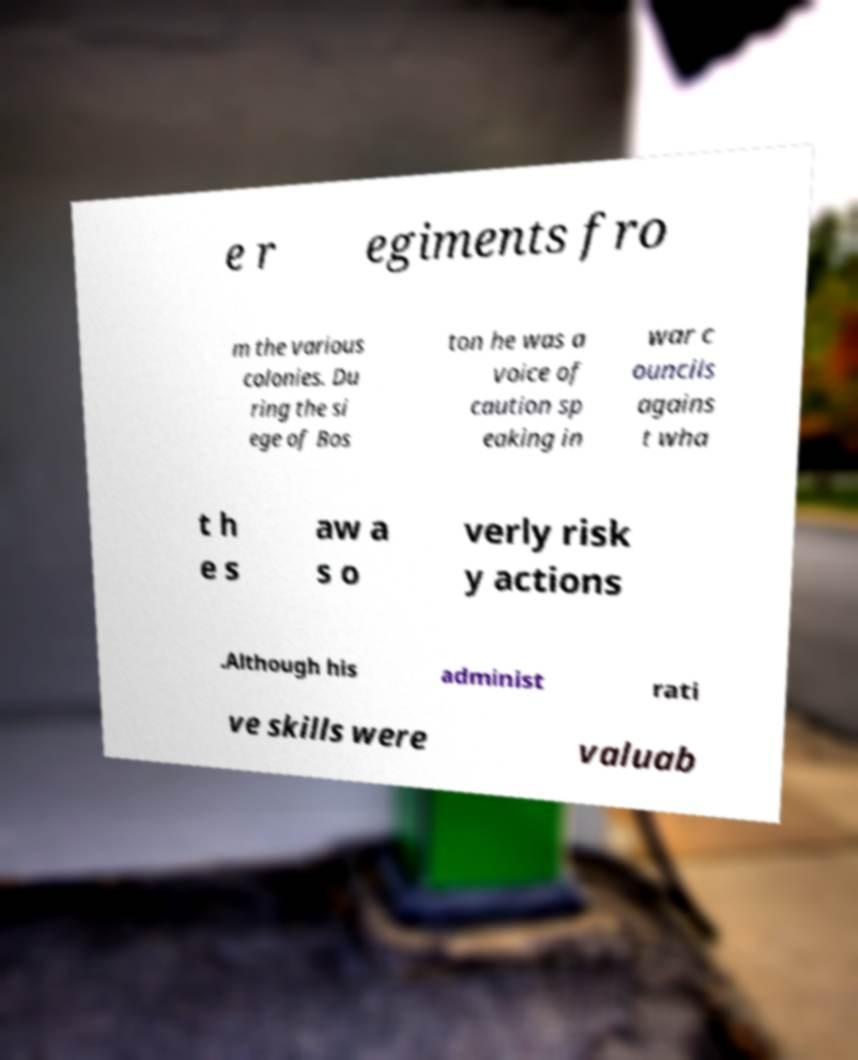Please identify and transcribe the text found in this image. e r egiments fro m the various colonies. Du ring the si ege of Bos ton he was a voice of caution sp eaking in war c ouncils agains t wha t h e s aw a s o verly risk y actions .Although his administ rati ve skills were valuab 